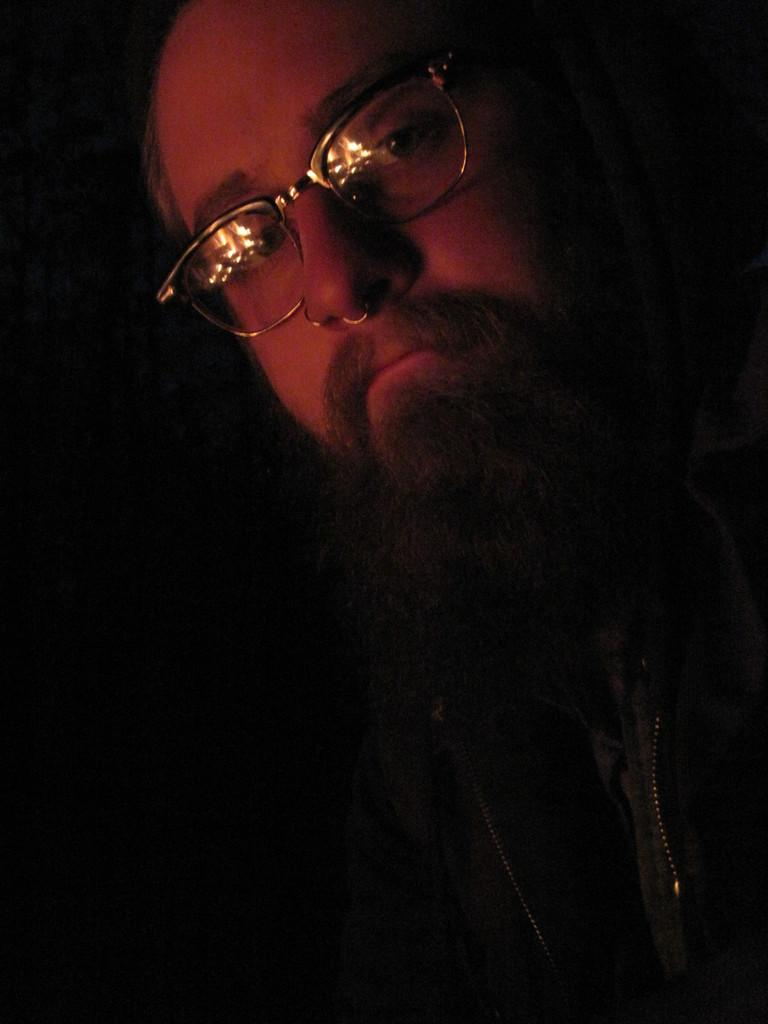Who is the main subject in the image? There is a man in the image. What can be observed about the man's appearance? The man is wearing glasses and has a big beard. What is the man doing in the image? The man is posing for the camera. What type of pet does the man have in the image? There is no pet visible in the image. How many beds are present in the image? There is no mention of beds in the image. 